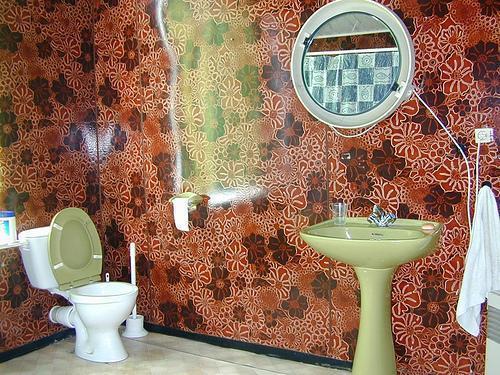How many men are wearing suits?
Give a very brief answer. 0. 